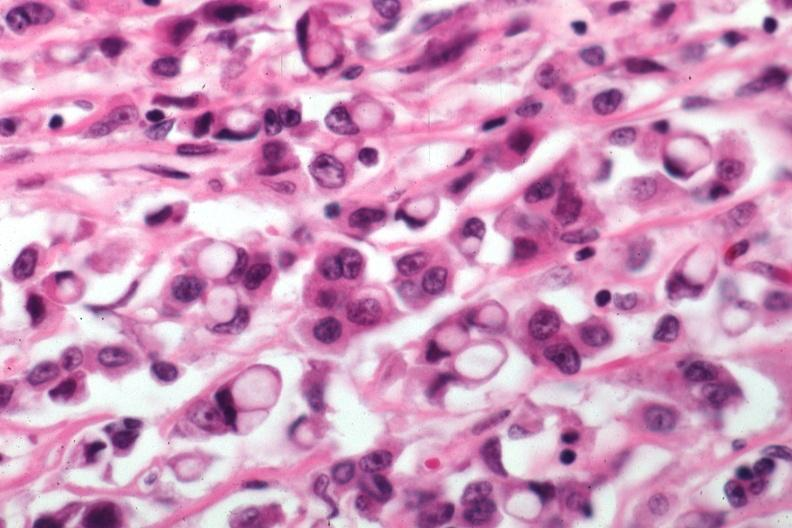what does this image show?
Answer the question using a single word or phrase. Pleomorphic cells with obvious mucin secretion 